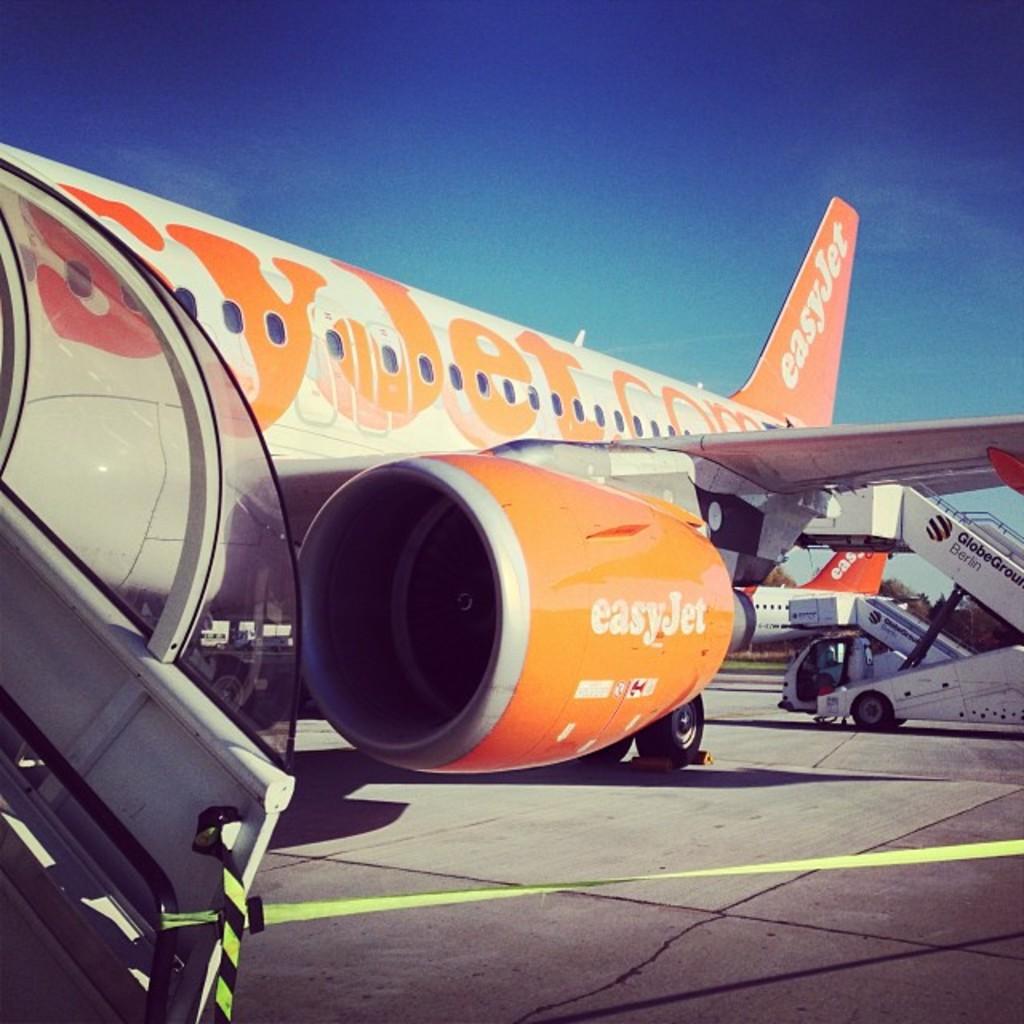What airline is this?
Provide a succinct answer. Easyjet. 